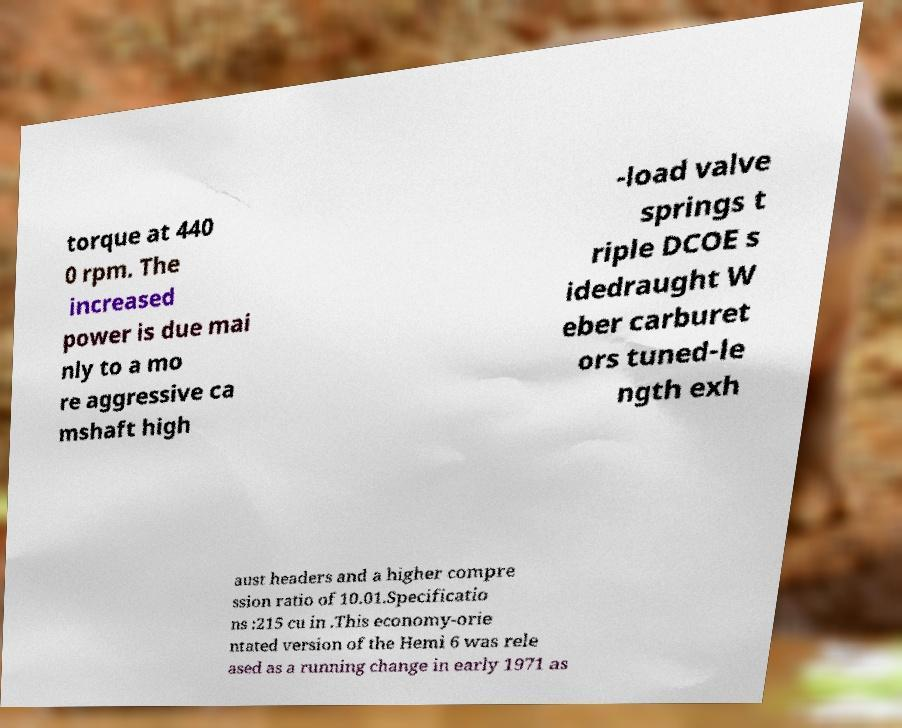Please identify and transcribe the text found in this image. torque at 440 0 rpm. The increased power is due mai nly to a mo re aggressive ca mshaft high -load valve springs t riple DCOE s idedraught W eber carburet ors tuned-le ngth exh aust headers and a higher compre ssion ratio of 10.01.Specificatio ns :215 cu in .This economy-orie ntated version of the Hemi 6 was rele ased as a running change in early 1971 as 